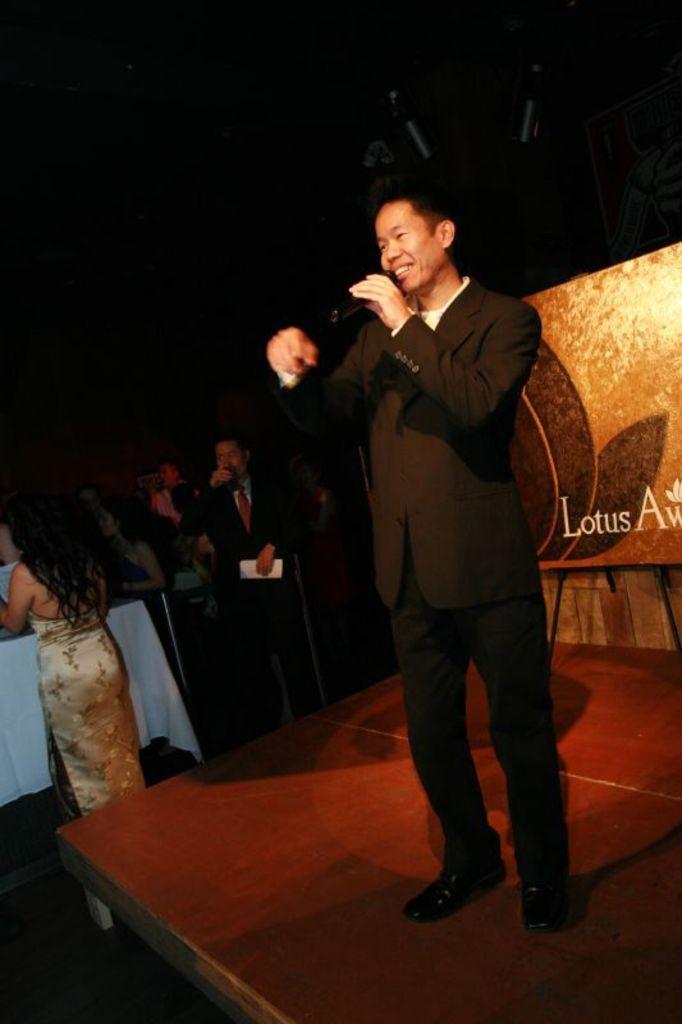Please provide a concise description of this image. In the center of the image we can see a man standing and holding a mic. In the background there are people. At the bottom there is dais. We can see a board. 